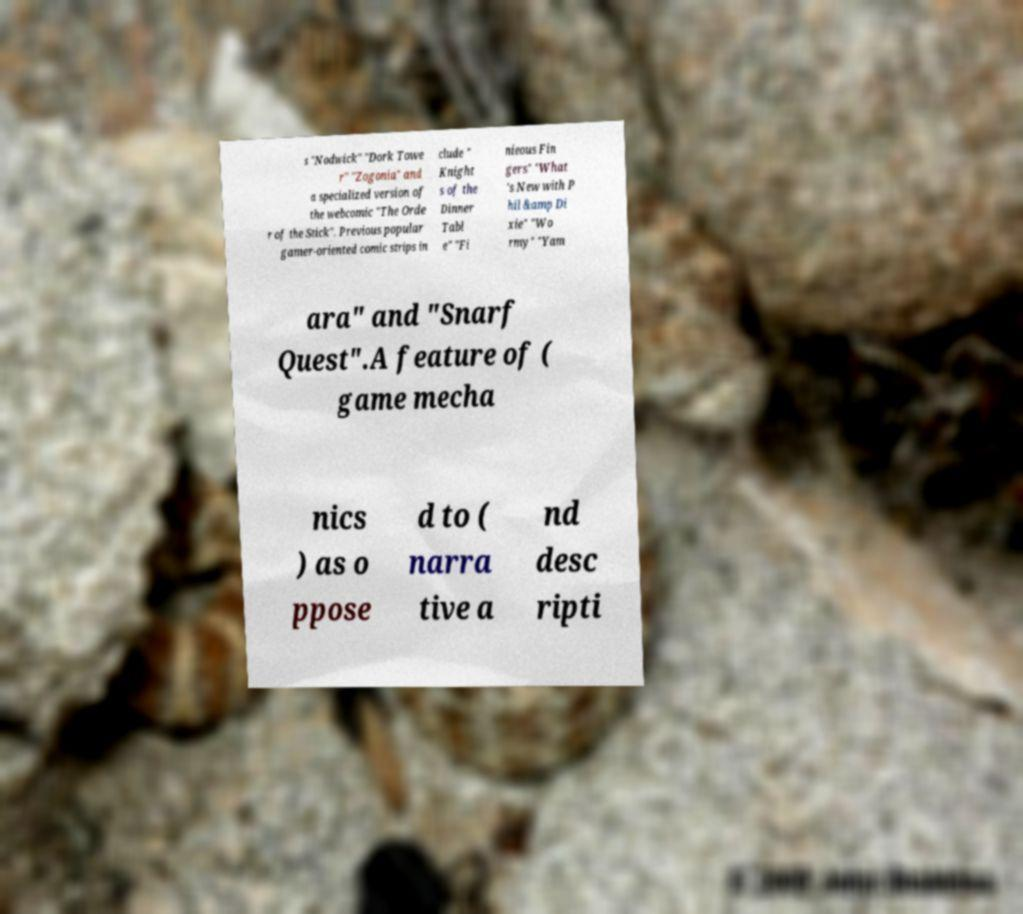For documentation purposes, I need the text within this image transcribed. Could you provide that? s "Nodwick" "Dork Towe r" "Zogonia" and a specialized version of the webcomic "The Orde r of the Stick". Previous popular gamer-oriented comic strips in clude " Knight s of the Dinner Tabl e" "Fi nieous Fin gers" "What 's New with P hil &amp Di xie" "Wo rmy" "Yam ara" and "Snarf Quest".A feature of ( game mecha nics ) as o ppose d to ( narra tive a nd desc ripti 